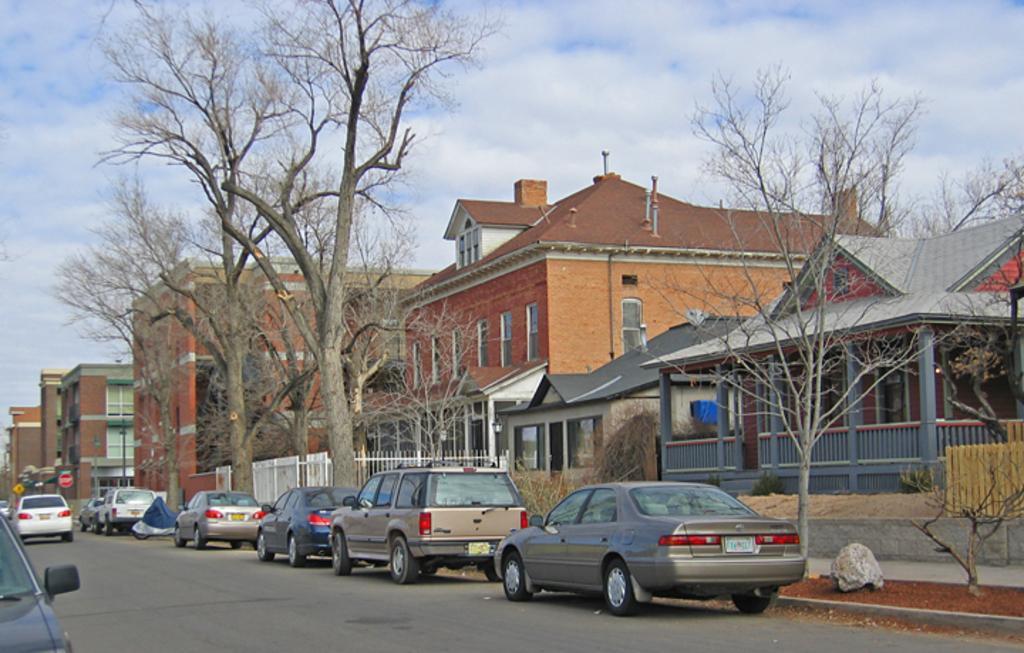Can you describe this image briefly? This is an outside view. At the bottom of the image I can see few cars on the road. In the background there are some buildings and trees. At the top, I can see the sky and clouds. 